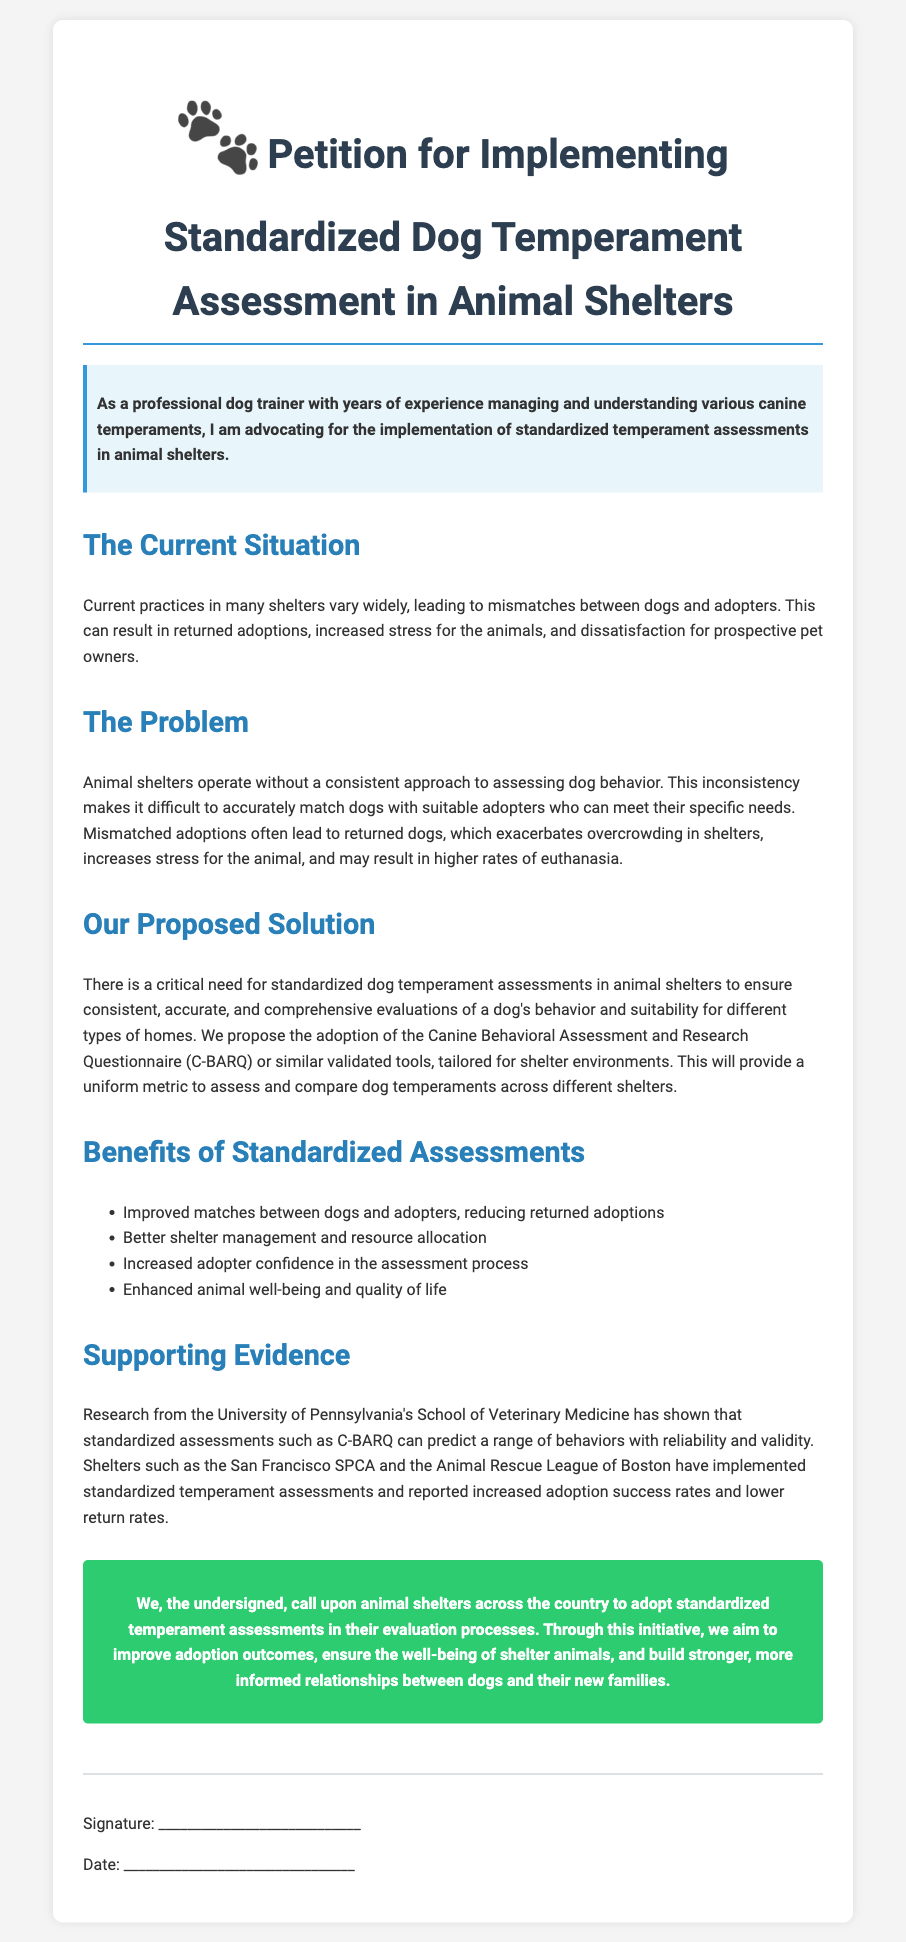what is the title of the petition? The title of the petition is presented at the beginning of the document.
Answer: Petition for Implementing Standardized Dog Temperament Assessment in Animal Shelters who is advocating for the implementation of standardized assessments? The document highlights a professional who has years of experience in dog training advocating for the assessments.
Answer: a professional dog trainer what is the main problem identified in the petition? The main problem stated in the document is about the inconsistency of evaluations in animal shelters.
Answer: Inconsistent assessments what tool is proposed for standardized assessments? The petition mentions a specific tool that could be used for standardizing assessments in shelters.
Answer: Canine Behavioral Assessment and Research Questionnaire (C-BARQ) what benefit is mentioned regarding adopter confidence? The document lists benefits that arise from standardized assessments, including one related to the confidence of adopters.
Answer: Increased adopter confidence how does the document describe the impact of mismatched adoptions? The document discusses the consequences of returning dogs due to mismatched adoptions.
Answer: Increased stress for animals what type of evidence supports the need for standardized assessments? The petition cites a type of research that validates the necessity for standardized assessments.
Answer: Research from the University of Pennsylvania's School of Veterinary Medicine what action do the undersigned call upon animal shelters to take? The conclusion of the petition clearly states what action the signers want animal shelters to adopt.
Answer: Adopt standardized temperament assessments how many benefits of standardized assessments are listed? The document contains a list of benefits related to the implementation of standardized assessments.
Answer: Four benefits 